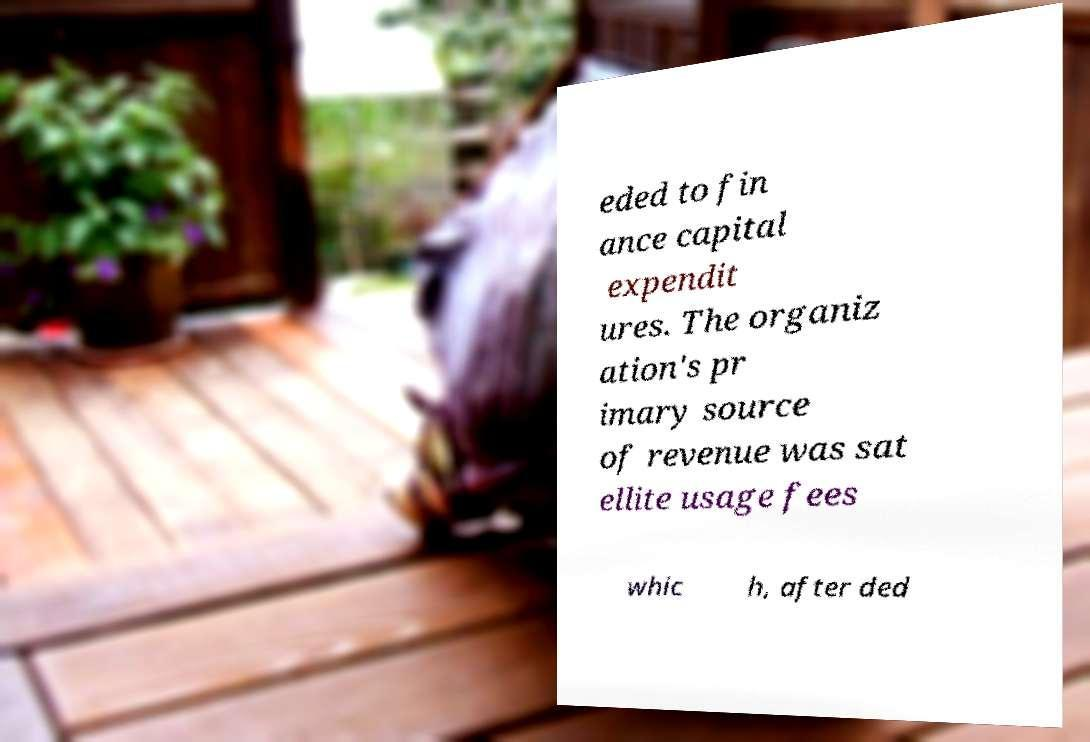For documentation purposes, I need the text within this image transcribed. Could you provide that? eded to fin ance capital expendit ures. The organiz ation's pr imary source of revenue was sat ellite usage fees whic h, after ded 